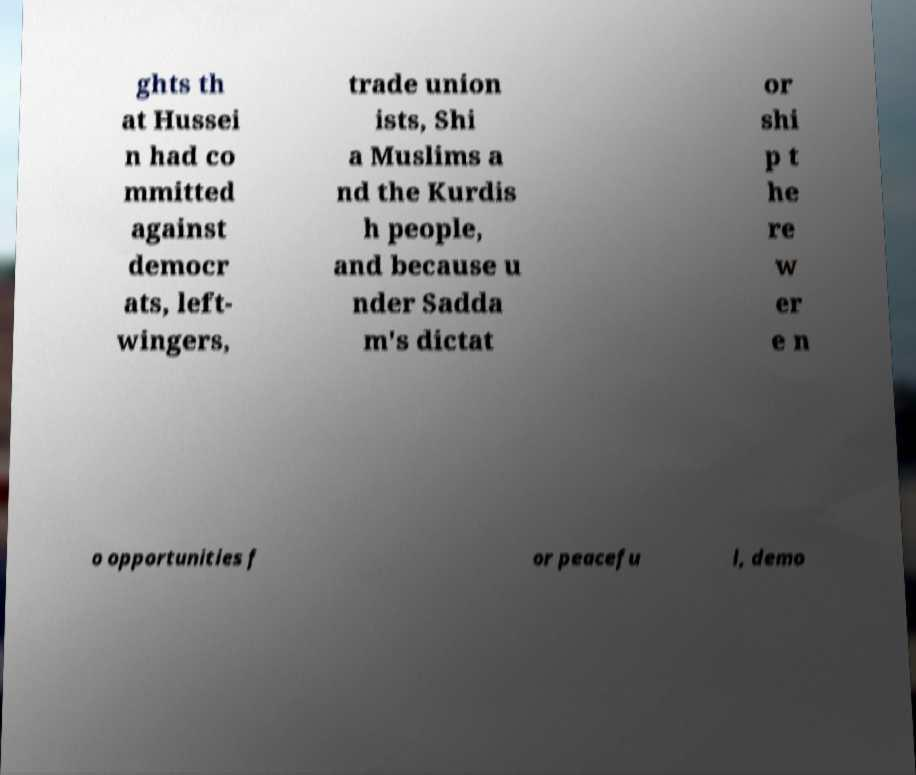I need the written content from this picture converted into text. Can you do that? ghts th at Hussei n had co mmitted against democr ats, left- wingers, trade union ists, Shi a Muslims a nd the Kurdis h people, and because u nder Sadda m's dictat or shi p t he re w er e n o opportunities f or peacefu l, demo 